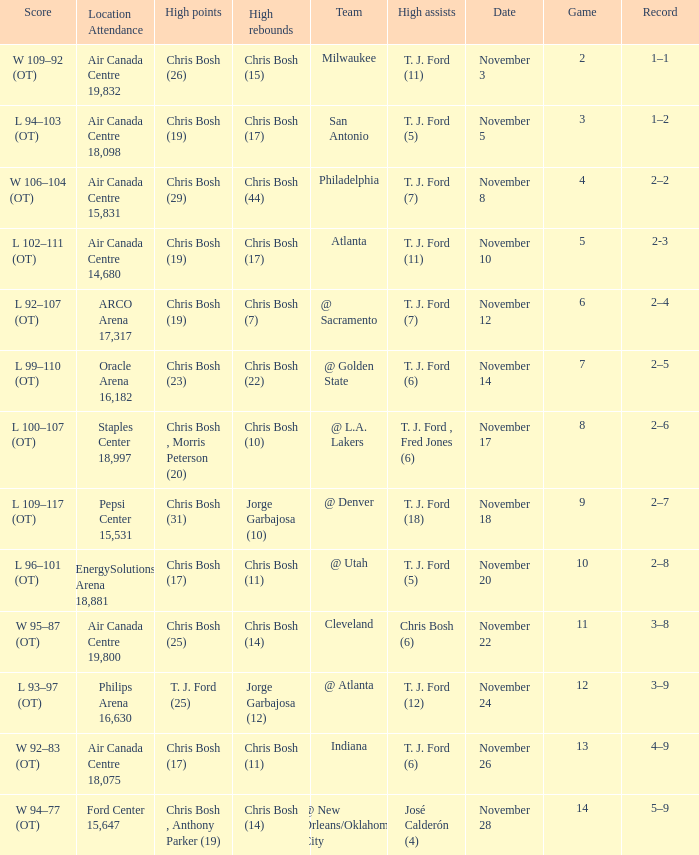What was the score of the game on November 12? L 92–107 (OT). 